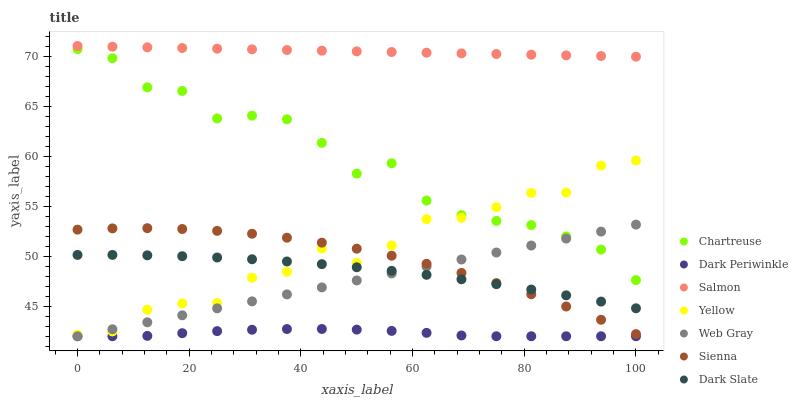Does Dark Periwinkle have the minimum area under the curve?
Answer yes or no. Yes. Does Salmon have the maximum area under the curve?
Answer yes or no. Yes. Does Yellow have the minimum area under the curve?
Answer yes or no. No. Does Yellow have the maximum area under the curve?
Answer yes or no. No. Is Web Gray the smoothest?
Answer yes or no. Yes. Is Chartreuse the roughest?
Answer yes or no. Yes. Is Salmon the smoothest?
Answer yes or no. No. Is Salmon the roughest?
Answer yes or no. No. Does Web Gray have the lowest value?
Answer yes or no. Yes. Does Yellow have the lowest value?
Answer yes or no. No. Does Salmon have the highest value?
Answer yes or no. Yes. Does Yellow have the highest value?
Answer yes or no. No. Is Dark Slate less than Chartreuse?
Answer yes or no. Yes. Is Chartreuse greater than Dark Slate?
Answer yes or no. Yes. Does Yellow intersect Chartreuse?
Answer yes or no. Yes. Is Yellow less than Chartreuse?
Answer yes or no. No. Is Yellow greater than Chartreuse?
Answer yes or no. No. Does Dark Slate intersect Chartreuse?
Answer yes or no. No. 